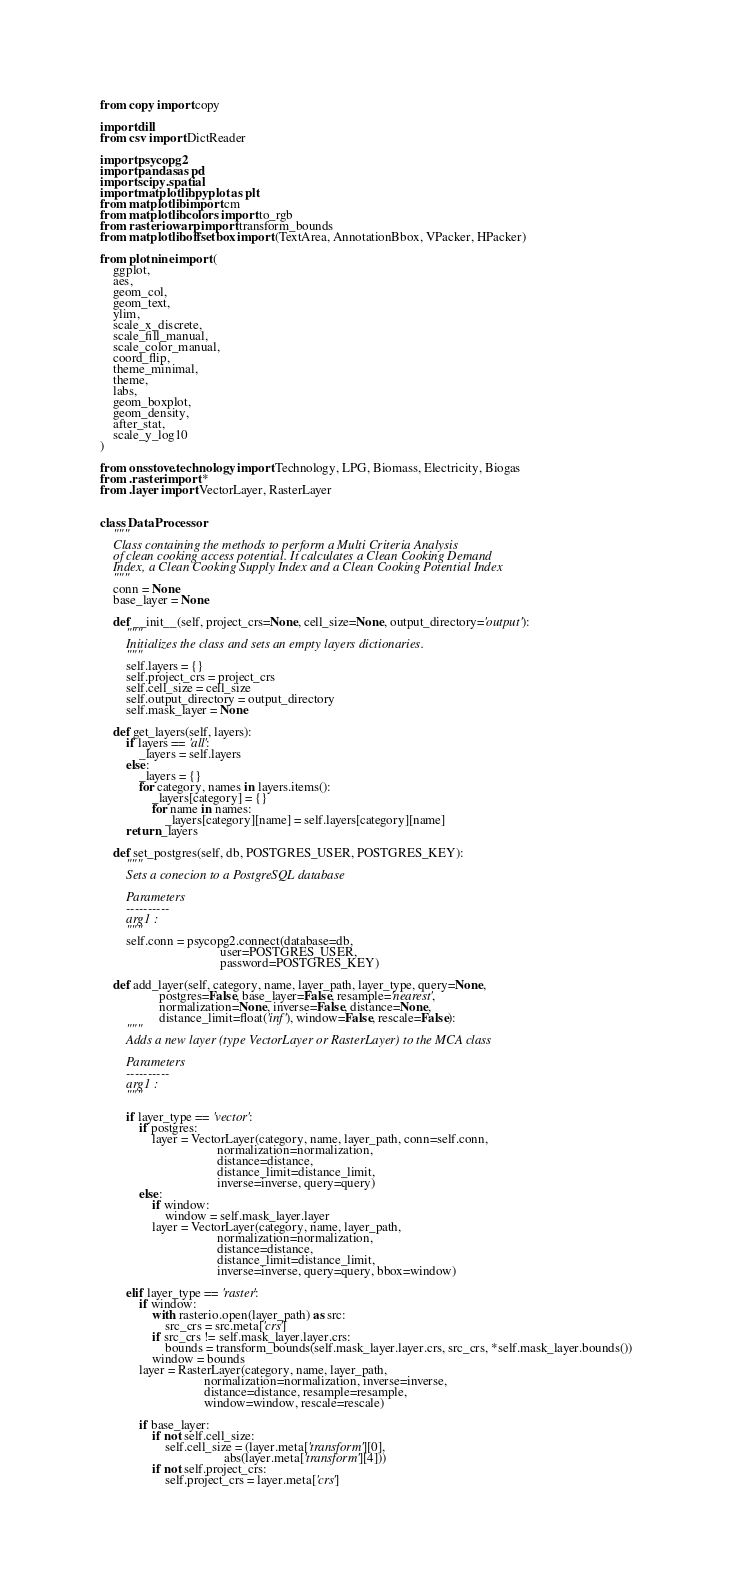<code> <loc_0><loc_0><loc_500><loc_500><_Python_>from copy import copy

import dill
from csv import DictReader

import psycopg2
import pandas as pd
import scipy.spatial
import matplotlib.pyplot as plt
from matplotlib import cm
from matplotlib.colors import to_rgb
from rasterio.warp import transform_bounds
from matplotlib.offsetbox import (TextArea, AnnotationBbox, VPacker, HPacker)

from plotnine import (
    ggplot,
    aes,
    geom_col,
    geom_text,
    ylim,
    scale_x_discrete,
    scale_fill_manual,
    scale_color_manual,
    coord_flip,
    theme_minimal,
    theme,
    labs,
    geom_boxplot,
    geom_density,
    after_stat,
    scale_y_log10
)

from onsstove.technology import Technology, LPG, Biomass, Electricity, Biogas
from .raster import *
from .layer import VectorLayer, RasterLayer


class DataProcessor:
    """
    Class containing the methods to perform a Multi Criteria Analysis
    of clean cooking access potential. It calculates a Clean Cooking Demand
    Index, a Clean Cooking Supply Index and a Clean Cooking Potential Index
    """
    conn = None
    base_layer = None

    def __init__(self, project_crs=None, cell_size=None, output_directory='output'):
        """
        Initializes the class and sets an empty layers dictionaries.
        """
        self.layers = {}
        self.project_crs = project_crs
        self.cell_size = cell_size
        self.output_directory = output_directory
        self.mask_layer = None

    def get_layers(self, layers):
        if layers == 'all':
            _layers = self.layers
        else:
            _layers = {}
            for category, names in layers.items():
                _layers[category] = {}
                for name in names:
                    _layers[category][name] = self.layers[category][name]
        return _layers

    def set_postgres(self, db, POSTGRES_USER, POSTGRES_KEY):
        """
        Sets a conecion to a PostgreSQL database

        Parameters
        ----------
        arg1 :
        """
        self.conn = psycopg2.connect(database=db,
                                     user=POSTGRES_USER,
                                     password=POSTGRES_KEY)

    def add_layer(self, category, name, layer_path, layer_type, query=None,
                  postgres=False, base_layer=False, resample='nearest',
                  normalization=None, inverse=False, distance=None,
                  distance_limit=float('inf'), window=False, rescale=False):
        """
        Adds a new layer (type VectorLayer or RasterLayer) to the MCA class

        Parameters
        ----------
        arg1 :
        """

        if layer_type == 'vector':
            if postgres:
                layer = VectorLayer(category, name, layer_path, conn=self.conn,
                                    normalization=normalization,
                                    distance=distance,
                                    distance_limit=distance_limit,
                                    inverse=inverse, query=query)
            else:
                if window:
                    window = self.mask_layer.layer
                layer = VectorLayer(category, name, layer_path,
                                    normalization=normalization,
                                    distance=distance,
                                    distance_limit=distance_limit,
                                    inverse=inverse, query=query, bbox=window)

        elif layer_type == 'raster':
            if window:
                with rasterio.open(layer_path) as src:
                    src_crs = src.meta['crs']
                if src_crs != self.mask_layer.layer.crs:
                    bounds = transform_bounds(self.mask_layer.layer.crs, src_crs, *self.mask_layer.bounds())
                window = bounds
            layer = RasterLayer(category, name, layer_path,
                                normalization=normalization, inverse=inverse,
                                distance=distance, resample=resample,
                                window=window, rescale=rescale)

            if base_layer:
                if not self.cell_size:
                    self.cell_size = (layer.meta['transform'][0],
                                      abs(layer.meta['transform'][4]))
                if not self.project_crs:
                    self.project_crs = layer.meta['crs']
</code> 